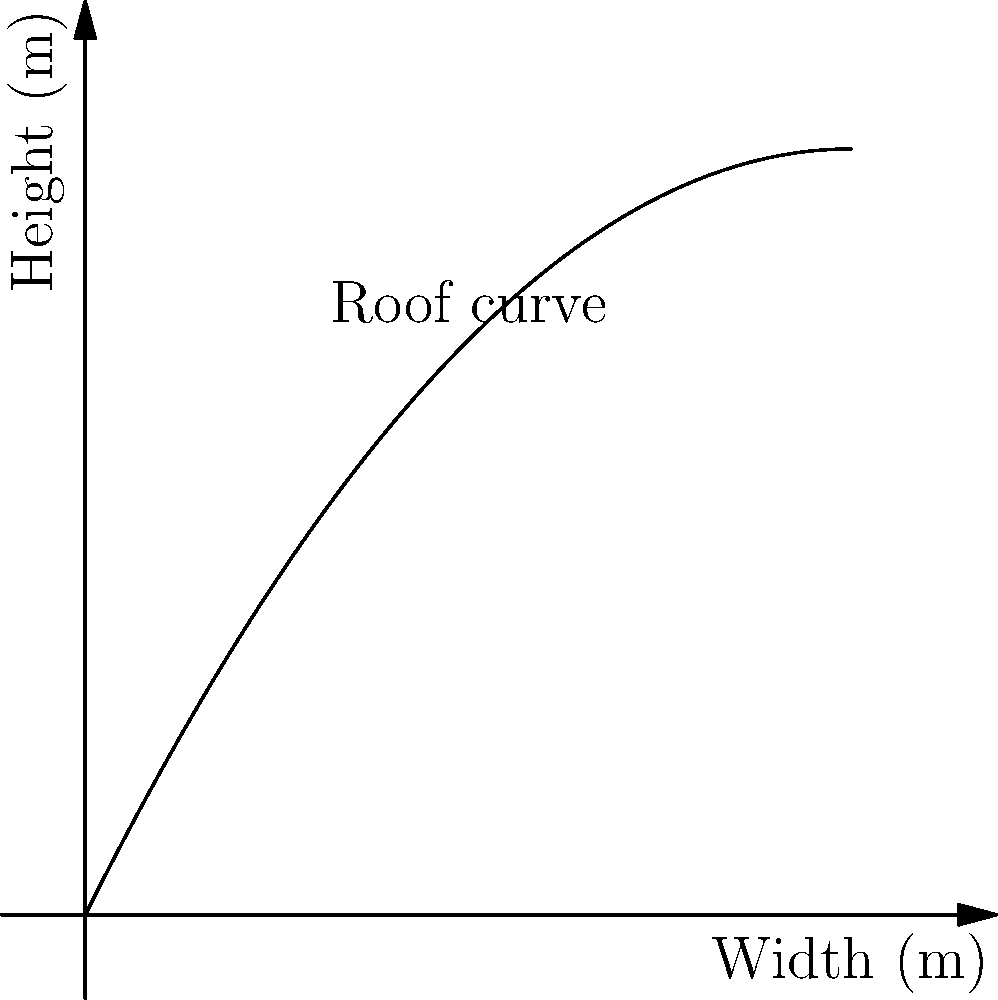You want to design an optimal curved roof for rainwater collection. The roof's shape can be modeled by the polynomial equation $h(x) = -0.1x^2 + 2x$, where $h$ is the height in meters and $x$ is the horizontal distance from the edge in meters. The roof spans 10 meters in width. What is the maximum height of the roof, and at what horizontal distance from the edge does this occur? To find the maximum height of the roof and its location, we need to follow these steps:

1) The function representing the roof's shape is $h(x) = -0.1x^2 + 2x$.

2) To find the maximum point, we need to find where the derivative of this function equals zero:
   $h'(x) = -0.2x + 2$

3) Set $h'(x) = 0$ and solve for $x$:
   $-0.2x + 2 = 0$
   $-0.2x = -2$
   $x = 10$

4) This x-value represents the horizontal distance from the edge where the maximum height occurs.

5) To find the maximum height, plug $x = 10$ into the original function:
   $h(10) = -0.1(10)^2 + 2(10)$
   $= -10 + 20$
   $= 10$

Therefore, the maximum height of the roof is 10 meters, occurring at a horizontal distance of 10 meters from the edge.
Answer: Maximum height: 10 meters; Location: 10 meters from the edge 